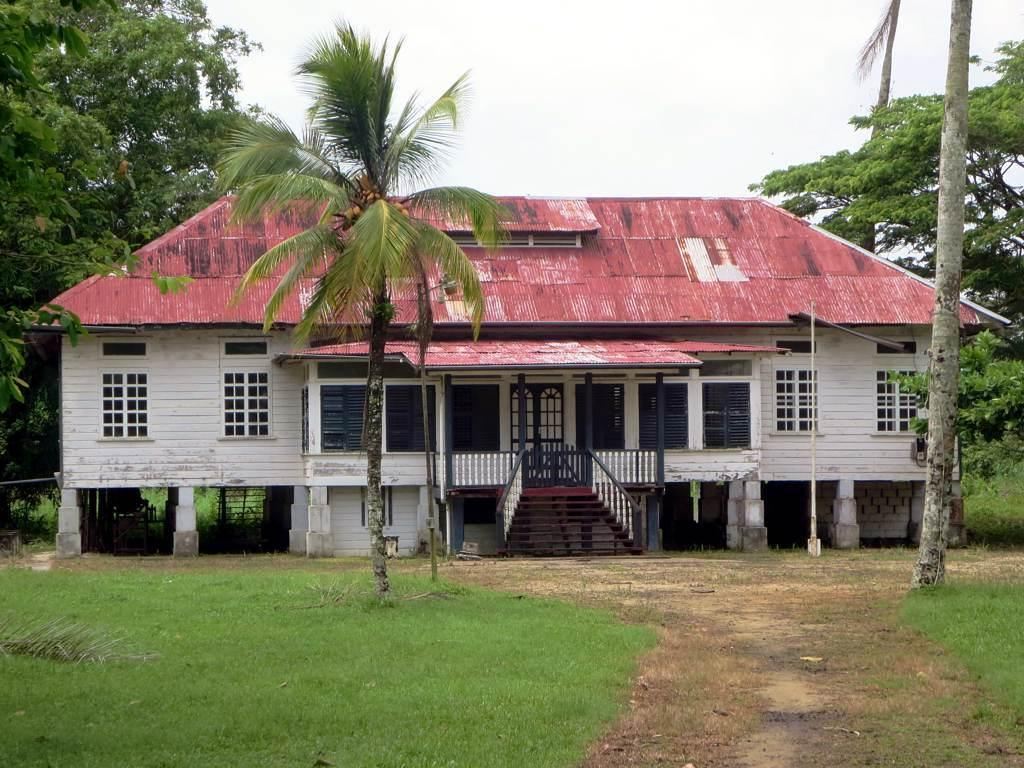What is the main subject in the center of the image? There is a house in the center of the image. What other object can be seen in the image? There is a tree in the image. Where are the trees located in relation to the house? There are trees at the bottom of the image. What can be seen in the background of the image? There are trees in the background of the image. Can you see a baby playing with a horn in the image? There is no baby or horn present in the image. 